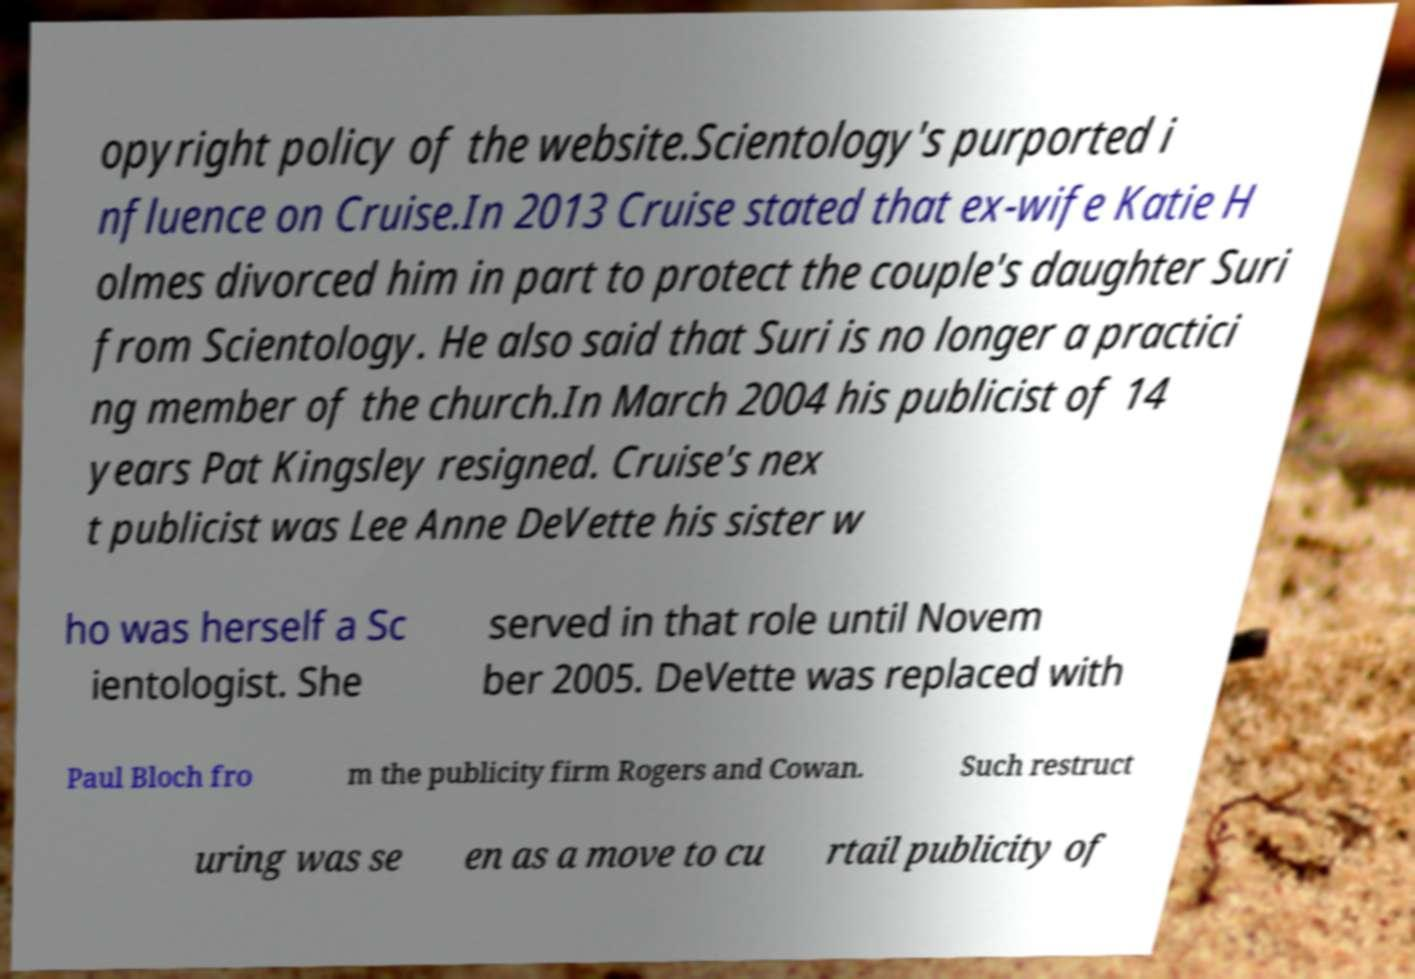For documentation purposes, I need the text within this image transcribed. Could you provide that? opyright policy of the website.Scientology's purported i nfluence on Cruise.In 2013 Cruise stated that ex-wife Katie H olmes divorced him in part to protect the couple's daughter Suri from Scientology. He also said that Suri is no longer a practici ng member of the church.In March 2004 his publicist of 14 years Pat Kingsley resigned. Cruise's nex t publicist was Lee Anne DeVette his sister w ho was herself a Sc ientologist. She served in that role until Novem ber 2005. DeVette was replaced with Paul Bloch fro m the publicity firm Rogers and Cowan. Such restruct uring was se en as a move to cu rtail publicity of 